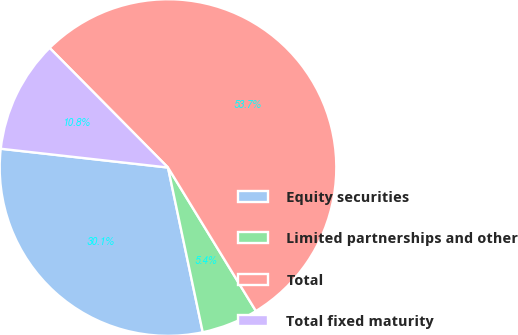Convert chart. <chart><loc_0><loc_0><loc_500><loc_500><pie_chart><fcel>Equity securities<fcel>Limited partnerships and other<fcel>Total<fcel>Total fixed maturity<nl><fcel>30.09%<fcel>5.44%<fcel>53.67%<fcel>10.8%<nl></chart> 